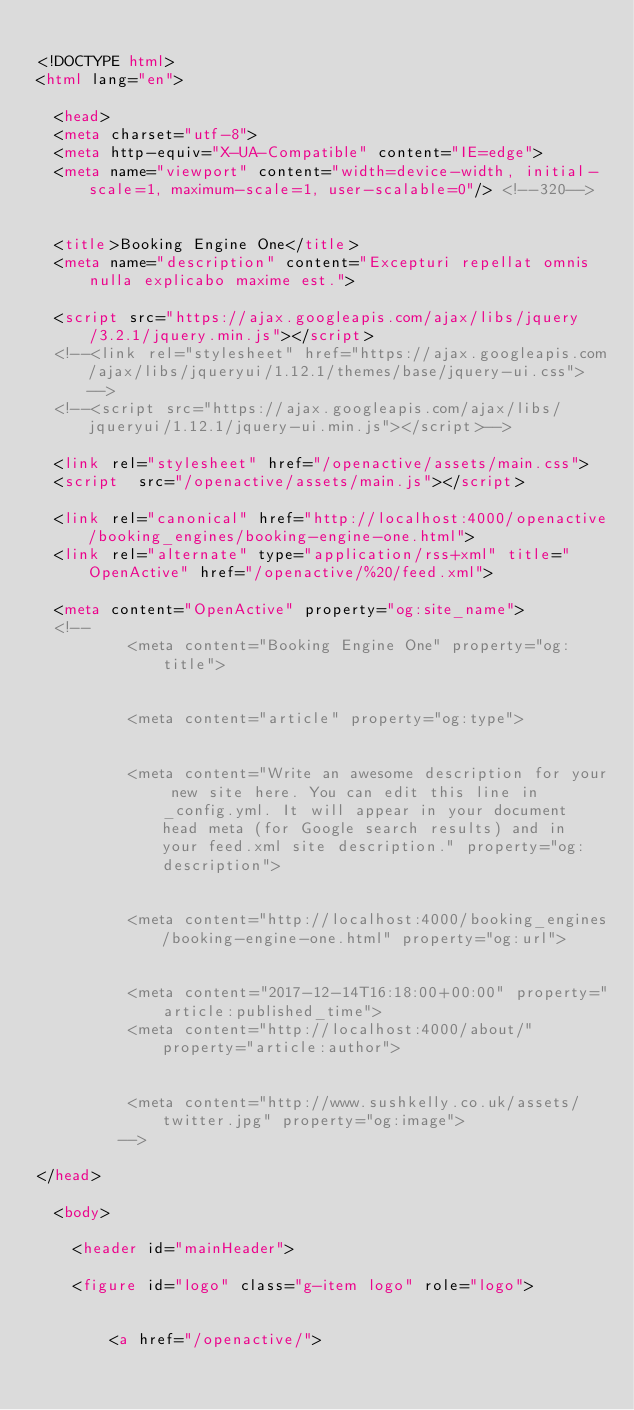<code> <loc_0><loc_0><loc_500><loc_500><_HTML_>
<!DOCTYPE html>
<html lang="en">

  <head>
  <meta charset="utf-8">
  <meta http-equiv="X-UA-Compatible" content="IE=edge">
  <meta name="viewport" content="width=device-width, initial-scale=1, maximum-scale=1, user-scalable=0"/> <!--320-->


  <title>Booking Engine One</title>
  <meta name="description" content="Excepturi repellat omnis nulla explicabo maxime est.">

  <script src="https://ajax.googleapis.com/ajax/libs/jquery/3.2.1/jquery.min.js"></script>
  <!--<link rel="stylesheet" href="https://ajax.googleapis.com/ajax/libs/jqueryui/1.12.1/themes/base/jquery-ui.css">-->
  <!--<script src="https://ajax.googleapis.com/ajax/libs/jqueryui/1.12.1/jquery-ui.min.js"></script>-->

  <link rel="stylesheet" href="/openactive/assets/main.css">
  <script  src="/openactive/assets/main.js"></script>

  <link rel="canonical" href="http://localhost:4000/openactive/booking_engines/booking-engine-one.html">
  <link rel="alternate" type="application/rss+xml" title="OpenActive" href="/openactive/%20/feed.xml">

  <meta content="OpenActive" property="og:site_name">
  <!-- 
          <meta content="Booking Engine One" property="og:title">
        
        
          <meta content="article" property="og:type">
        
        
          <meta content="Write an awesome description for your new site here. You can edit this line in _config.yml. It will appear in your document head meta (for Google search results) and in your feed.xml site description." property="og:description">
        
        
          <meta content="http://localhost:4000/booking_engines/booking-engine-one.html" property="og:url">
        
        
          <meta content="2017-12-14T16:18:00+00:00" property="article:published_time">
          <meta content="http://localhost:4000/about/" property="article:author">
        
        
          <meta content="http://www.sushkelly.co.uk/assets/twitter.jpg" property="og:image">
         -->
         
</head>

  <body>

    <header id="mainHeader">

    <figure id="logo" class="g-item logo" role="logo">
        
        
        <a href="/openactive/">
</code> 